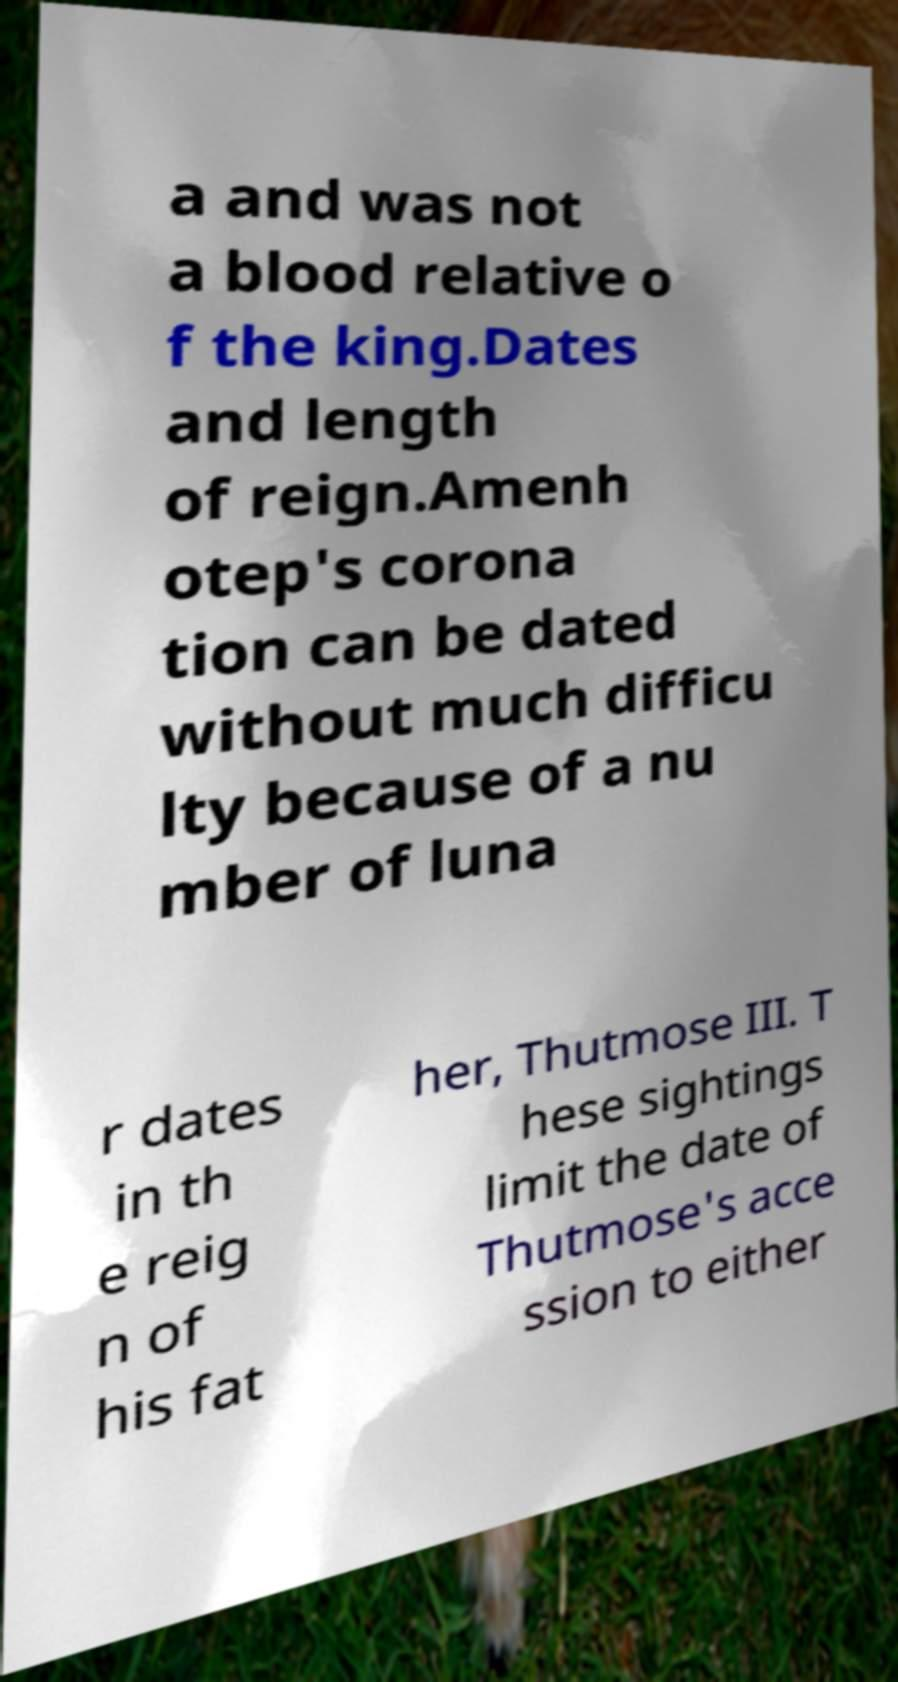For documentation purposes, I need the text within this image transcribed. Could you provide that? a and was not a blood relative o f the king.Dates and length of reign.Amenh otep's corona tion can be dated without much difficu lty because of a nu mber of luna r dates in th e reig n of his fat her, Thutmose III. T hese sightings limit the date of Thutmose's acce ssion to either 